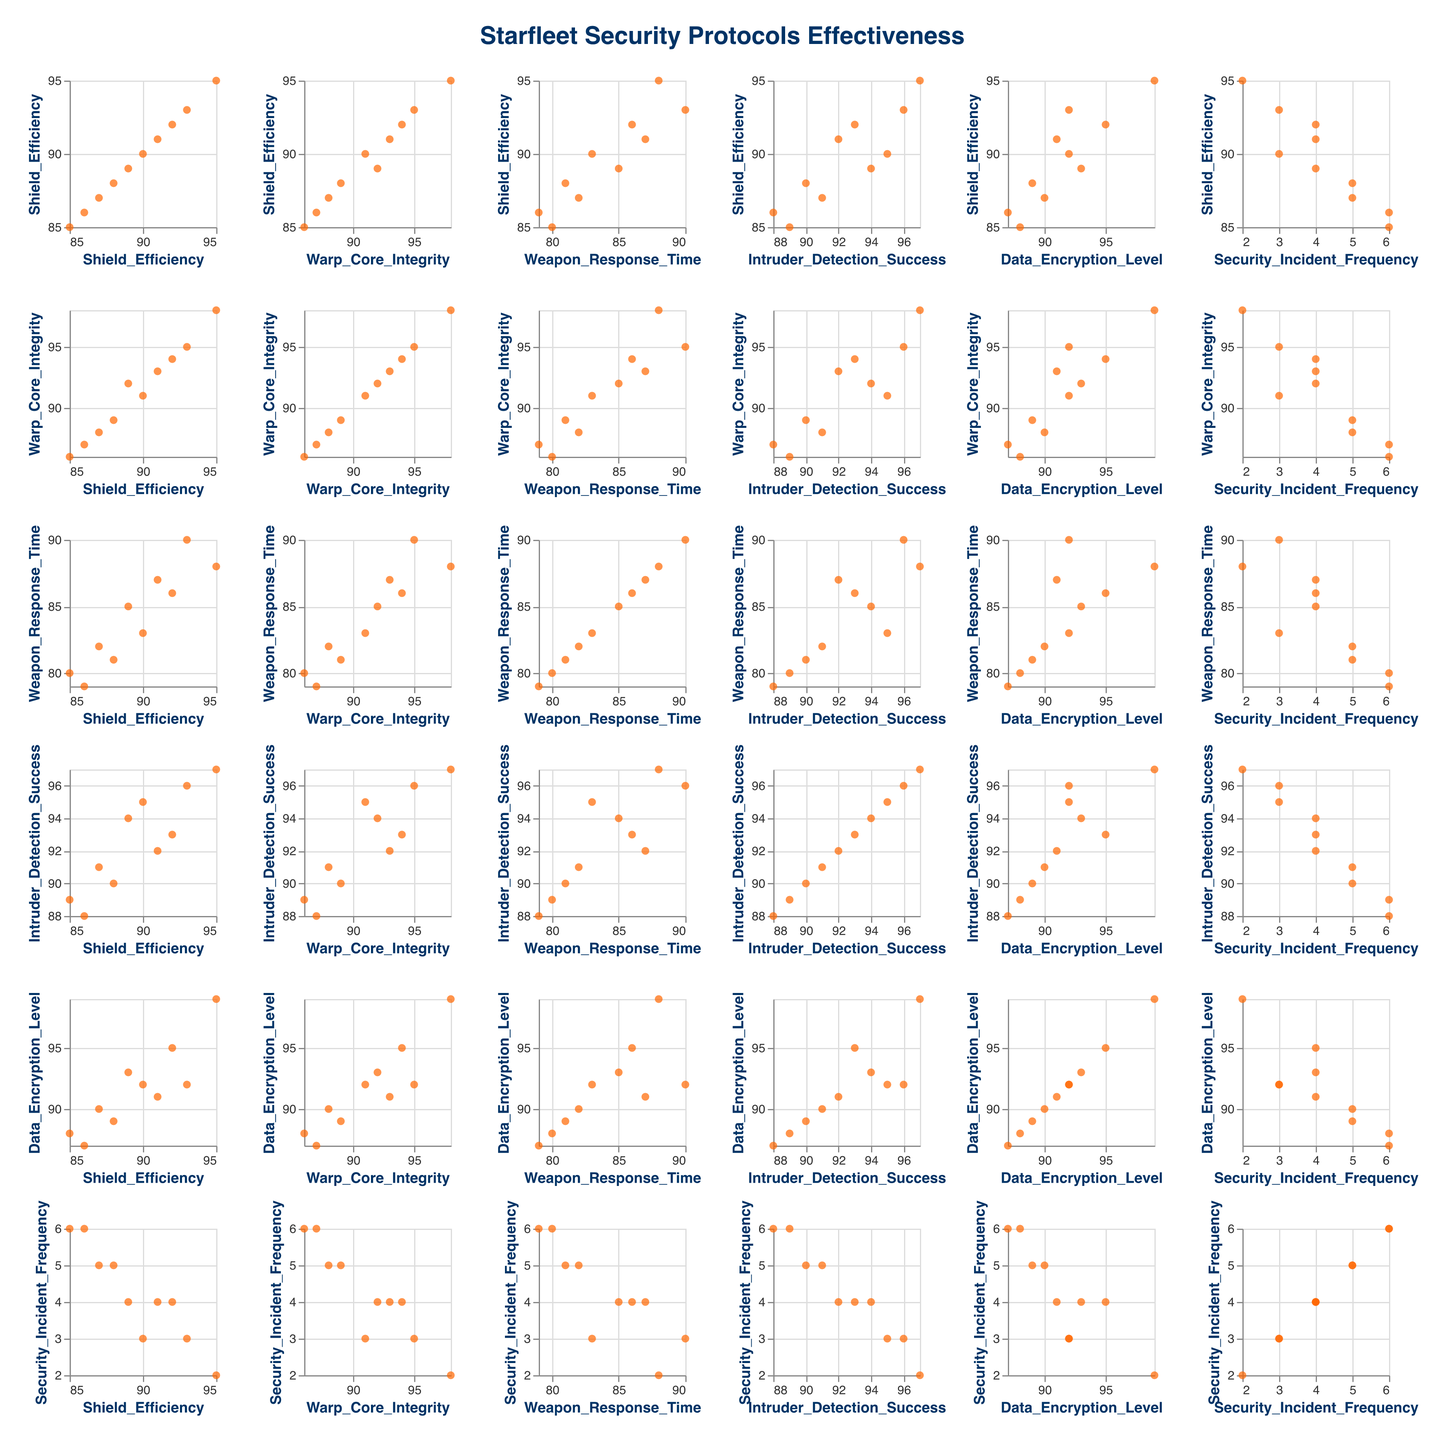what's the title of the figure? The title is displayed at the top of the figure, describing the content it represents. It reads "Starfleet Security Protocols Effectiveness."
Answer: Starfleet Security Protocols Effectiveness how many different Starfleet ships are represented in the SPLOM? Each point in the scatter plot represents a different Starfleet ship. If we check the data, we find ten unique ships listed.
Answer: 10 which ship has the highest Data Encryption Level? By examining the data points in the Data Encryption Level axis, the tooltip information, or the corresponding scatter plots, we can identify that USS Enterprise has a Data Encryption Level of 99, the highest among all ships.
Answer: USS Enterprise what is the relationship between Intruder Detection Success and Shield Efficiency across the ships? By observing the scatter plot that compares Intruder Detection Success on the y-axis and Shield Efficiency on the x-axis, one can note if there's a general trend. Most points are clustered in the upper-right area, suggesting that higher Shield Efficiency tends to coincide with higher Intruder Detection Success.
Answer: Positive correlation which metrics show the lowest and highest variability among the ships? To determine this, examine the range of values along each axis in the scatter plot matrix. The Security Incident Frequency ranges from 2 to 6, showing the least variability, while Warp Core Integrity ranges from 86 to 98, indicating higher variability.
Answer: Security Incident Frequency (lowest), Warp Core Integrity (highest) do ships with higher Warp Core Integrity generally have faster Weapon Response Time? Check the subplot comparing Warp Core Integrity on the x-axis and Weapon Response Time on the y-axis. Generally, points with higher x-values (Warp Core Integrity) have lower y-values (Weapon Response Time), suggesting a slight negative correlation.
Answer: Slight negative correlation which ship has the most frequent security incidents, and how does its Shield Efficiency compare with others? By inspecting the scatter plot where Security Incident Frequency is on the y-axis, look for the highest point. USS Constellation and USS Oberth both show the highest frequency (6 incidents). Comparing their Shield Efficiency, both ships fall in the lower range, around 85-86.
Answer: USS Constellation and USS Oberth, with Shield Efficiency around 85-86 which two ships have the closest Weapon Response Time? Look for points close together in the subplot of Weapon Response Time on both axes. USS Excelsior and USS Yorktown both have Weapon Response Times of 82 and 81, respectively, indicating closeness.
Answer: USS Excelsior and USS Yorktown how does the overall shield efficiency trend correlate with security incident frequency? Examining the matrix subplot that compares Shield Efficiency on the x-axis and Security Incident Frequency on the y-axis reveals a negative trend, where higher Shield Efficiency correlates with lower Security Incident Frequency, indicated by downward-sloping points.
Answer: Negative correlation 